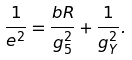Convert formula to latex. <formula><loc_0><loc_0><loc_500><loc_500>\frac { 1 } { e ^ { 2 } } = \frac { b R } { g _ { 5 } ^ { 2 } } + \frac { 1 } { g _ { Y } ^ { 2 } } .</formula> 